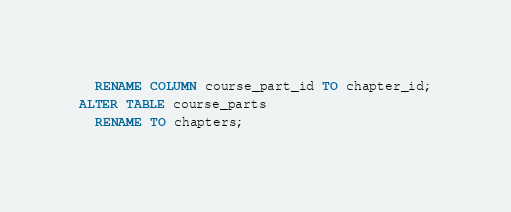Convert code to text. <code><loc_0><loc_0><loc_500><loc_500><_SQL_>  RENAME COLUMN course_part_id TO chapter_id;
ALTER TABLE course_parts
  RENAME TO chapters;
</code> 